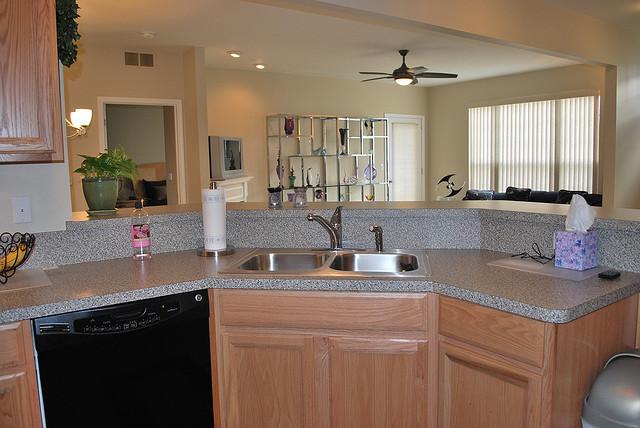How many lights are hanging?
Short answer required. 1. How many sinks are there?
Answer briefly. 2. Which room of the house is this?
Keep it brief. Kitchen. Where is the ivy?
Be succinct. Cabinet. Do you see a fan in the counter?
Be succinct. No. Are there plates on the counter?
Answer briefly. No. Are there dishes in the dish drainer?
Give a very brief answer. No. What is the countertop made of?
Concise answer only. Granite. Is it reasonable to assume that the dishes in the sink will be washed by hand or dishwasher?
Short answer required. Dishwasher. What room is this?
Give a very brief answer. Kitchen. How many lights are on?
Write a very short answer. 5. Is this a kitchen?
Give a very brief answer. Yes. What color are the cabinets?
Answer briefly. Brown. What room of the house is this?
Concise answer only. Kitchen. Who made the dish soap that color?
Short answer required. Manufacturer. 